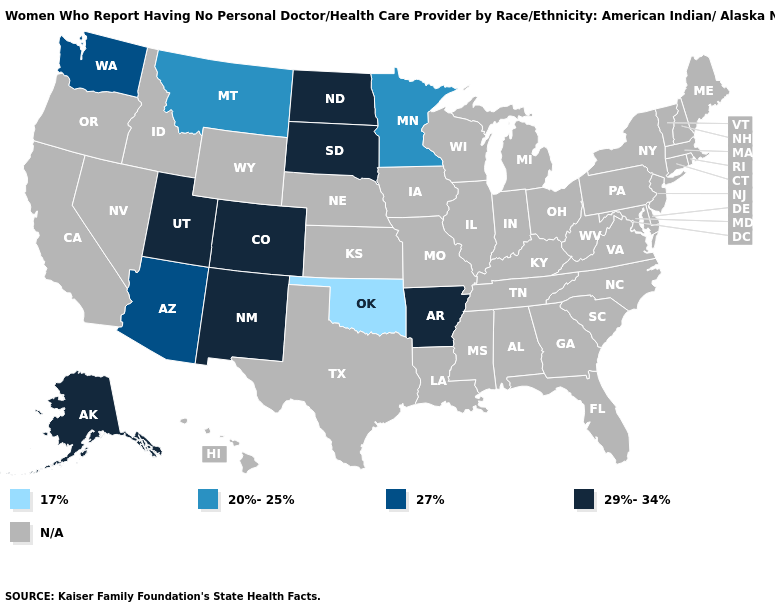Name the states that have a value in the range 20%-25%?
Write a very short answer. Minnesota, Montana. Name the states that have a value in the range 20%-25%?
Write a very short answer. Minnesota, Montana. Name the states that have a value in the range N/A?
Give a very brief answer. Alabama, California, Connecticut, Delaware, Florida, Georgia, Hawaii, Idaho, Illinois, Indiana, Iowa, Kansas, Kentucky, Louisiana, Maine, Maryland, Massachusetts, Michigan, Mississippi, Missouri, Nebraska, Nevada, New Hampshire, New Jersey, New York, North Carolina, Ohio, Oregon, Pennsylvania, Rhode Island, South Carolina, Tennessee, Texas, Vermont, Virginia, West Virginia, Wisconsin, Wyoming. Name the states that have a value in the range 20%-25%?
Be succinct. Minnesota, Montana. Among the states that border Colorado , does Arizona have the highest value?
Give a very brief answer. No. Does the first symbol in the legend represent the smallest category?
Keep it brief. Yes. Name the states that have a value in the range 29%-34%?
Short answer required. Alaska, Arkansas, Colorado, New Mexico, North Dakota, South Dakota, Utah. Name the states that have a value in the range 20%-25%?
Quick response, please. Minnesota, Montana. Does Minnesota have the lowest value in the MidWest?
Give a very brief answer. Yes. What is the highest value in states that border Kansas?
Concise answer only. 29%-34%. Which states have the highest value in the USA?
Concise answer only. Alaska, Arkansas, Colorado, New Mexico, North Dakota, South Dakota, Utah. Which states have the lowest value in the South?
Quick response, please. Oklahoma. What is the value of Colorado?
Quick response, please. 29%-34%. Name the states that have a value in the range 17%?
Quick response, please. Oklahoma. 